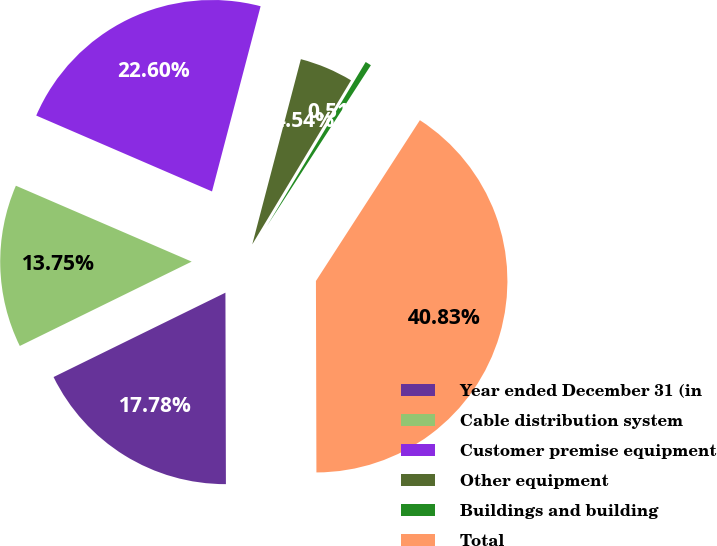Convert chart to OTSL. <chart><loc_0><loc_0><loc_500><loc_500><pie_chart><fcel>Year ended December 31 (in<fcel>Cable distribution system<fcel>Customer premise equipment<fcel>Other equipment<fcel>Buildings and building<fcel>Total<nl><fcel>17.78%<fcel>13.75%<fcel>22.6%<fcel>4.54%<fcel>0.51%<fcel>40.83%<nl></chart> 